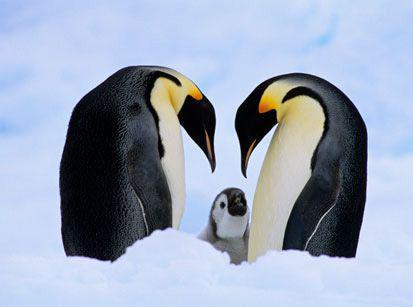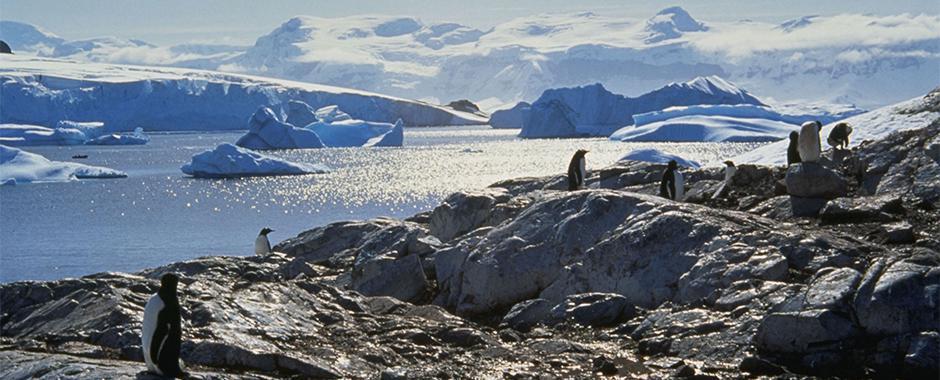The first image is the image on the left, the second image is the image on the right. Examine the images to the left and right. Is the description "One of the images depicts exactly three penguins." accurate? Answer yes or no. Yes. 